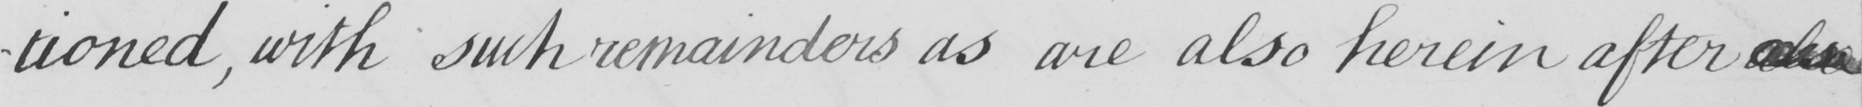What text is written in this handwritten line? -tioned , with such remainders as are also herein after also 